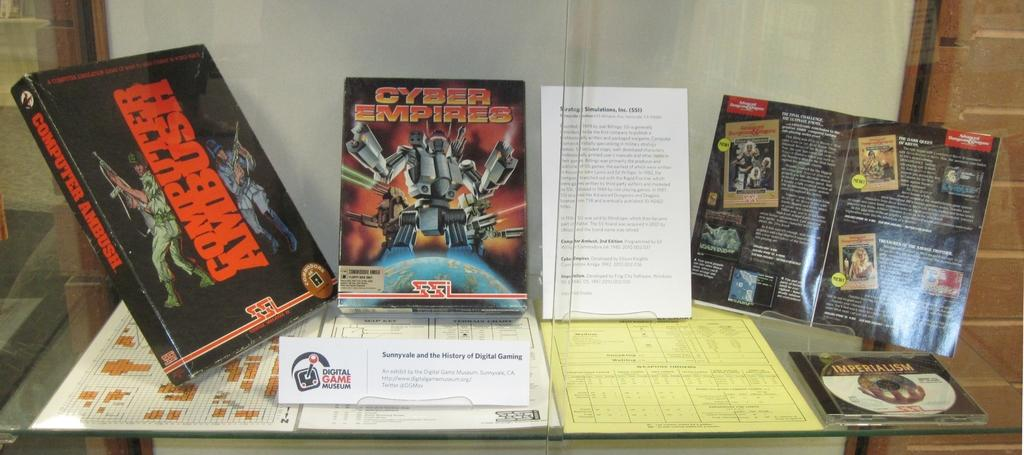<image>
Render a clear and concise summary of the photo. a few books with one being called computer ambush 